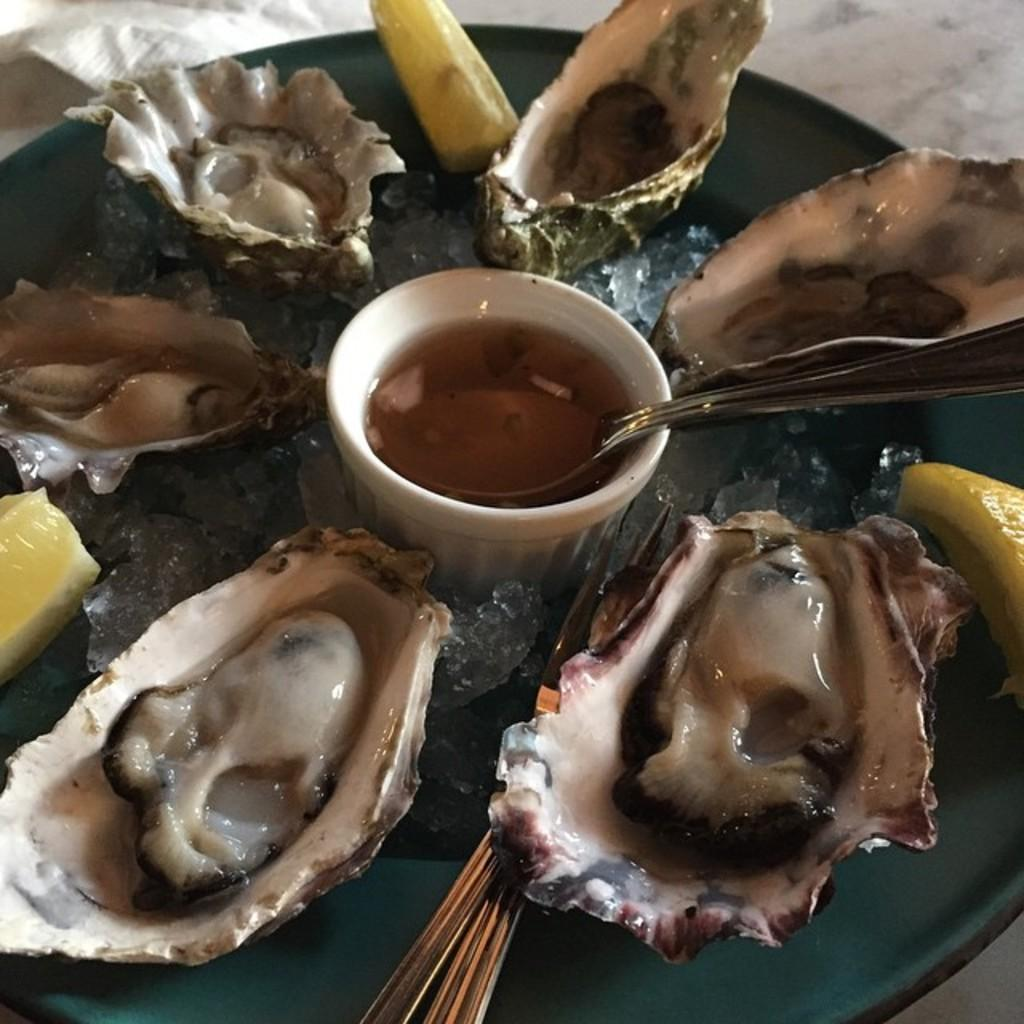What type of food is on the plate in the image? There is seafood on a plate in the image. What else can be seen in the image besides the plate of seafood? There is a bowl filled with liquid in the image. What is the temperature of the oven in the image? There is no oven present in the image. 